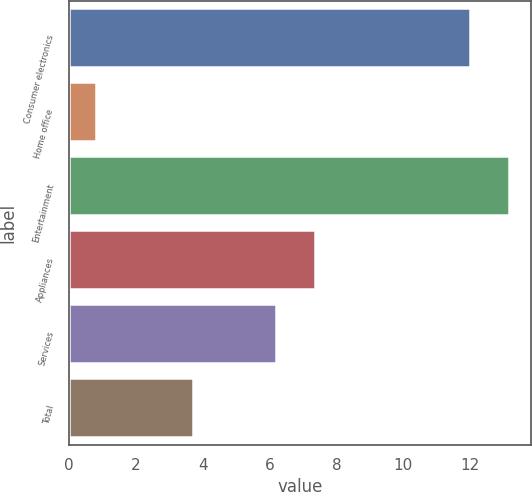Convert chart. <chart><loc_0><loc_0><loc_500><loc_500><bar_chart><fcel>Consumer electronics<fcel>Home office<fcel>Entertainment<fcel>Appliances<fcel>Services<fcel>Total<nl><fcel>12<fcel>0.8<fcel>13.16<fcel>7.36<fcel>6.2<fcel>3.7<nl></chart> 